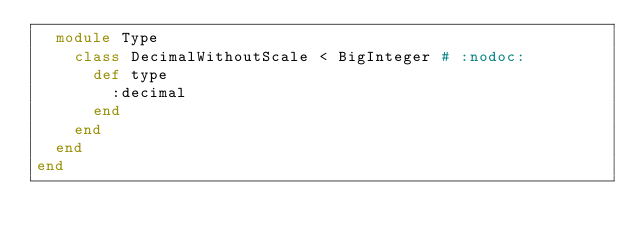<code> <loc_0><loc_0><loc_500><loc_500><_Ruby_>  module Type
    class DecimalWithoutScale < BigInteger # :nodoc:
      def type
        :decimal
      end
    end
  end
end
</code> 